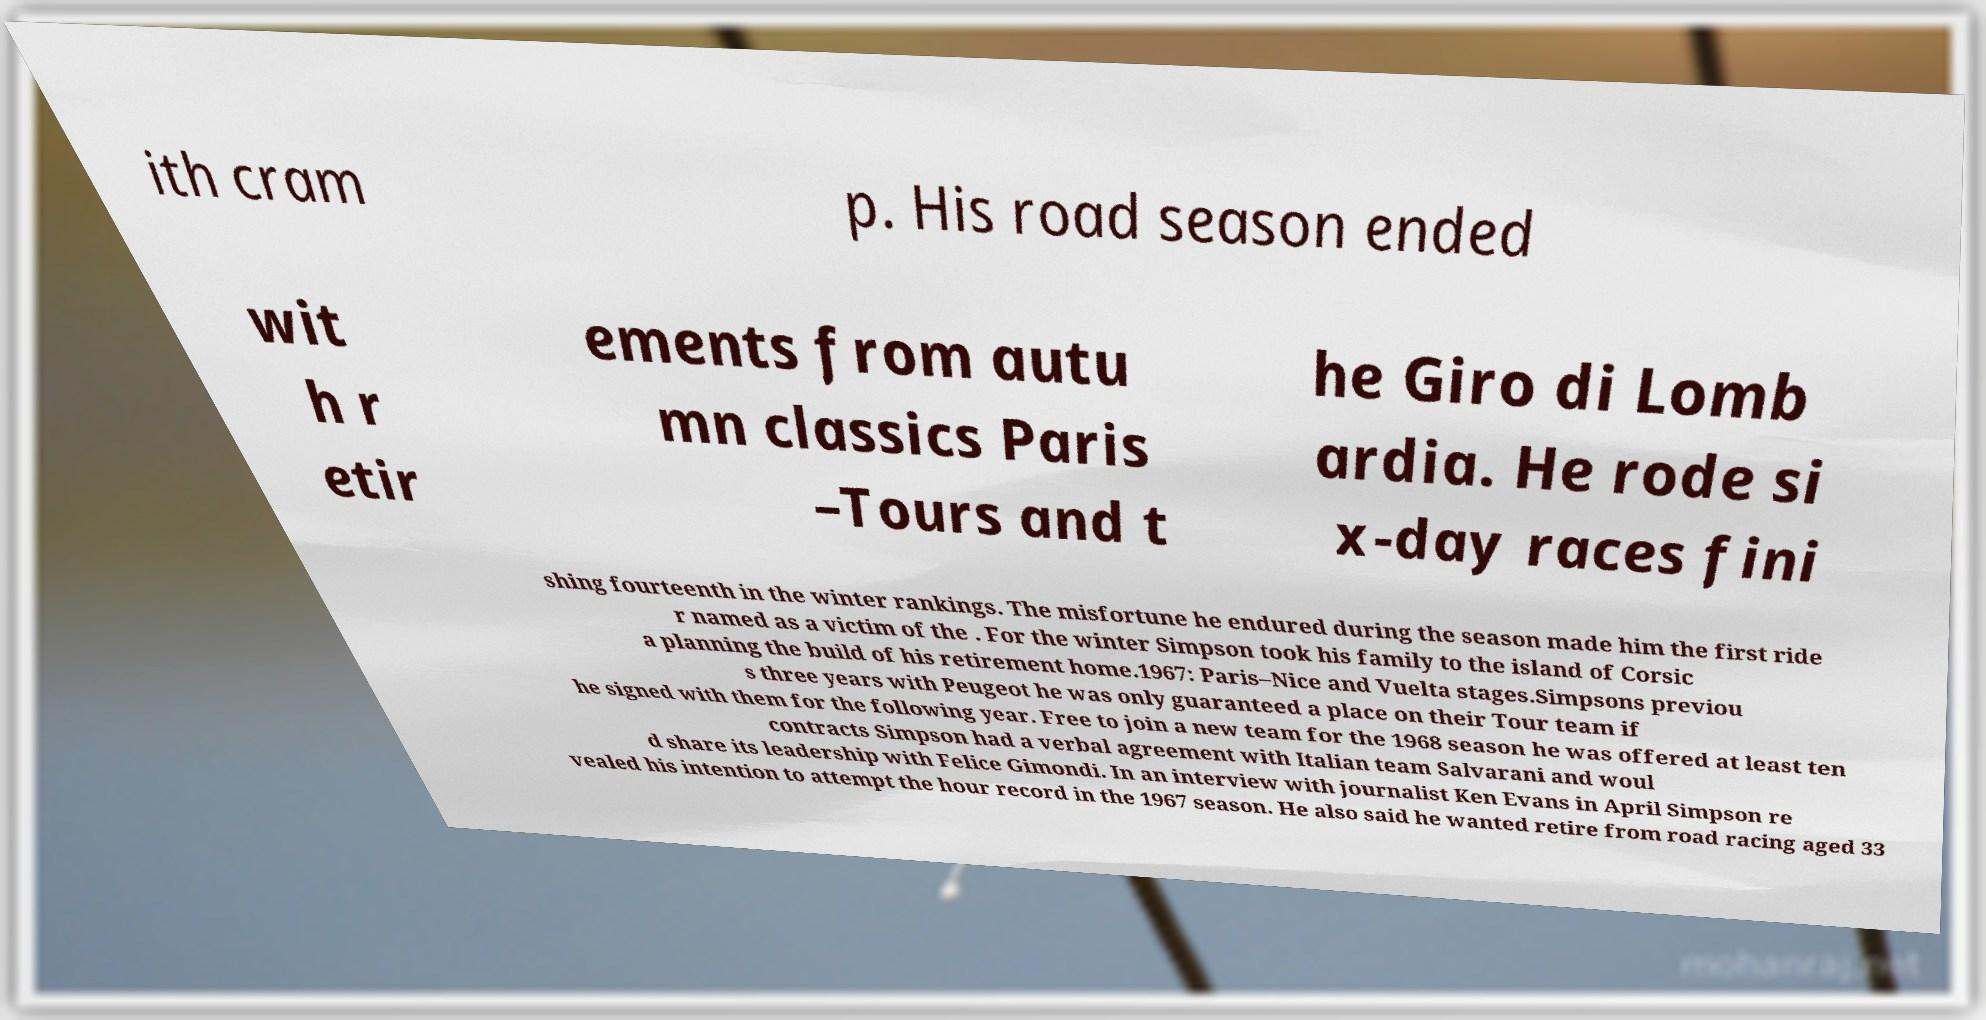Could you extract and type out the text from this image? ith cram p. His road season ended wit h r etir ements from autu mn classics Paris –Tours and t he Giro di Lomb ardia. He rode si x-day races fini shing fourteenth in the winter rankings. The misfortune he endured during the season made him the first ride r named as a victim of the . For the winter Simpson took his family to the island of Corsic a planning the build of his retirement home.1967: Paris–Nice and Vuelta stages.Simpsons previou s three years with Peugeot he was only guaranteed a place on their Tour team if he signed with them for the following year. Free to join a new team for the 1968 season he was offered at least ten contracts Simpson had a verbal agreement with Italian team Salvarani and woul d share its leadership with Felice Gimondi. In an interview with journalist Ken Evans in April Simpson re vealed his intention to attempt the hour record in the 1967 season. He also said he wanted retire from road racing aged 33 